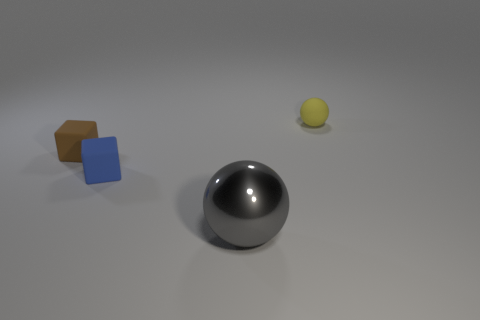Add 3 brown things. How many brown things exist? 4 Add 3 tiny brown objects. How many objects exist? 7 Subtract all gray balls. How many balls are left? 1 Subtract 0 brown cylinders. How many objects are left? 4 Subtract 1 cubes. How many cubes are left? 1 Subtract all brown blocks. Subtract all blue balls. How many blocks are left? 1 Subtract all red blocks. How many gray spheres are left? 1 Subtract all large cyan rubber spheres. Subtract all metal objects. How many objects are left? 3 Add 2 small brown blocks. How many small brown blocks are left? 3 